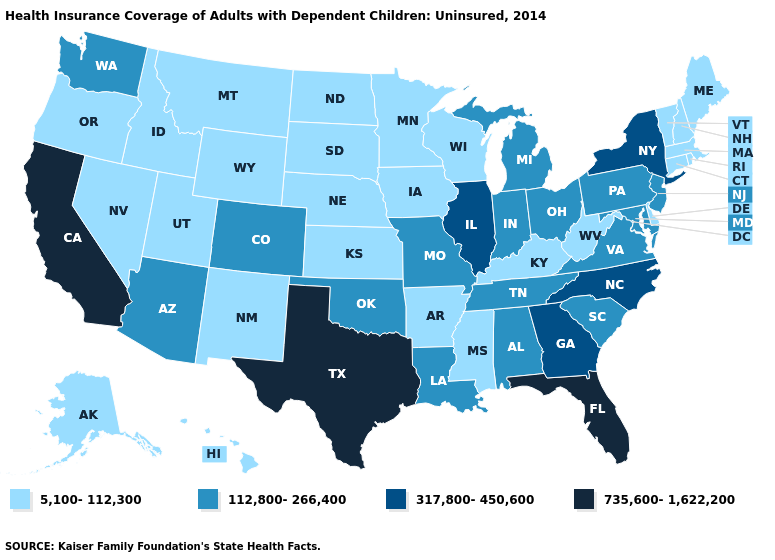Does the map have missing data?
Short answer required. No. What is the value of Rhode Island?
Concise answer only. 5,100-112,300. Is the legend a continuous bar?
Short answer required. No. Which states hav the highest value in the West?
Answer briefly. California. Does Texas have the highest value in the South?
Answer briefly. Yes. What is the value of Arkansas?
Write a very short answer. 5,100-112,300. Name the states that have a value in the range 112,800-266,400?
Give a very brief answer. Alabama, Arizona, Colorado, Indiana, Louisiana, Maryland, Michigan, Missouri, New Jersey, Ohio, Oklahoma, Pennsylvania, South Carolina, Tennessee, Virginia, Washington. Name the states that have a value in the range 735,600-1,622,200?
Short answer required. California, Florida, Texas. Which states have the highest value in the USA?
Give a very brief answer. California, Florida, Texas. What is the value of Alabama?
Give a very brief answer. 112,800-266,400. Which states have the highest value in the USA?
Keep it brief. California, Florida, Texas. Name the states that have a value in the range 735,600-1,622,200?
Keep it brief. California, Florida, Texas. Name the states that have a value in the range 735,600-1,622,200?
Give a very brief answer. California, Florida, Texas. Name the states that have a value in the range 735,600-1,622,200?
Short answer required. California, Florida, Texas. Name the states that have a value in the range 735,600-1,622,200?
Quick response, please. California, Florida, Texas. 